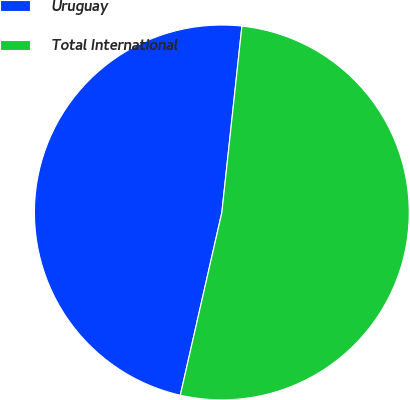Convert chart. <chart><loc_0><loc_0><loc_500><loc_500><pie_chart><fcel>Uruguay<fcel>Total International<nl><fcel>48.15%<fcel>51.85%<nl></chart> 